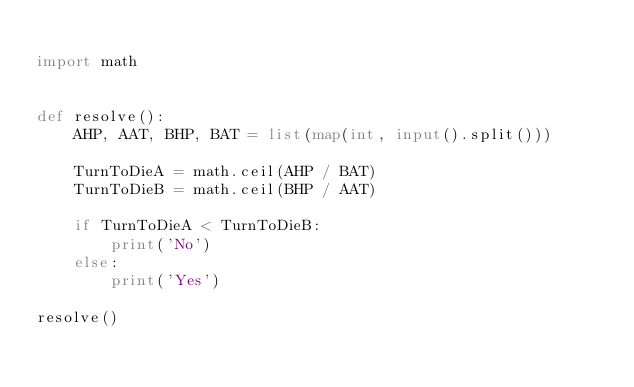Convert code to text. <code><loc_0><loc_0><loc_500><loc_500><_Python_>
import math


def resolve():
    AHP, AAT, BHP, BAT = list(map(int, input().split()))

    TurnToDieA = math.ceil(AHP / BAT)
    TurnToDieB = math.ceil(BHP / AAT)

    if TurnToDieA < TurnToDieB:
        print('No')
    else:
        print('Yes')

resolve()</code> 